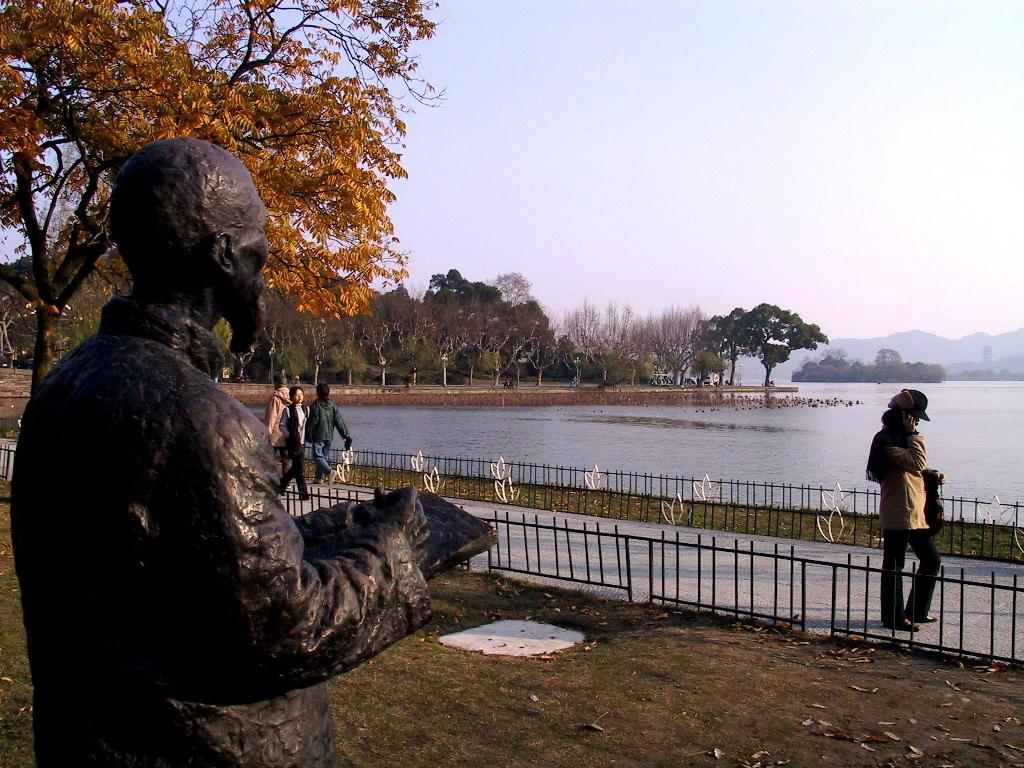What are the people in the image doing? There are persons walking in the image. What can be seen on the left side of the image? There is a statue on the left side of the image. What type of vegetation is visible in the image? There are trees visible in the image. What is the water surface in the image? The water surface is visible in the image. What is visible at the top of the image? The sky is visible at the top of the image. How many cups are being held by the persons walking in the image? There is no mention of cups in the image, so we cannot determine the number of cups being held. 